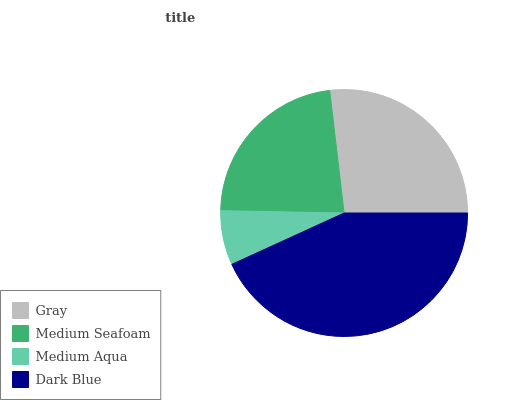Is Medium Aqua the minimum?
Answer yes or no. Yes. Is Dark Blue the maximum?
Answer yes or no. Yes. Is Medium Seafoam the minimum?
Answer yes or no. No. Is Medium Seafoam the maximum?
Answer yes or no. No. Is Gray greater than Medium Seafoam?
Answer yes or no. Yes. Is Medium Seafoam less than Gray?
Answer yes or no. Yes. Is Medium Seafoam greater than Gray?
Answer yes or no. No. Is Gray less than Medium Seafoam?
Answer yes or no. No. Is Gray the high median?
Answer yes or no. Yes. Is Medium Seafoam the low median?
Answer yes or no. Yes. Is Medium Seafoam the high median?
Answer yes or no. No. Is Medium Aqua the low median?
Answer yes or no. No. 